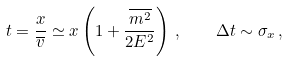<formula> <loc_0><loc_0><loc_500><loc_500>t = \frac { x } { \overline { v } } \simeq x \left ( 1 + \frac { \overline { m ^ { 2 } } } { 2 E ^ { 2 } } \right ) \, , \quad \Delta t \sim \sigma _ { x } \, ,</formula> 